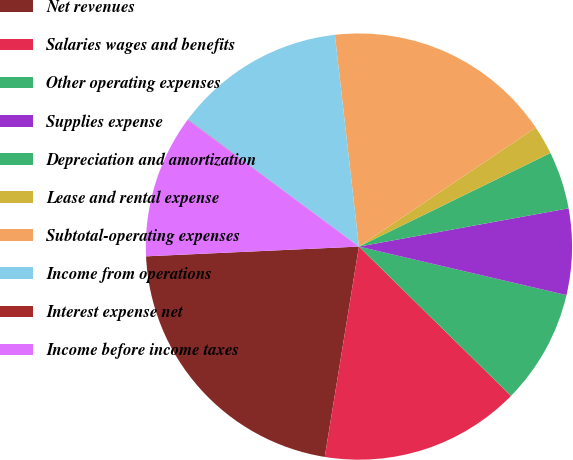Convert chart to OTSL. <chart><loc_0><loc_0><loc_500><loc_500><pie_chart><fcel>Net revenues<fcel>Salaries wages and benefits<fcel>Other operating expenses<fcel>Supplies expense<fcel>Depreciation and amortization<fcel>Lease and rental expense<fcel>Subtotal-operating expenses<fcel>Income from operations<fcel>Interest expense net<fcel>Income before income taxes<nl><fcel>21.71%<fcel>15.21%<fcel>8.7%<fcel>6.53%<fcel>4.36%<fcel>2.19%<fcel>17.38%<fcel>13.04%<fcel>0.02%<fcel>10.87%<nl></chart> 